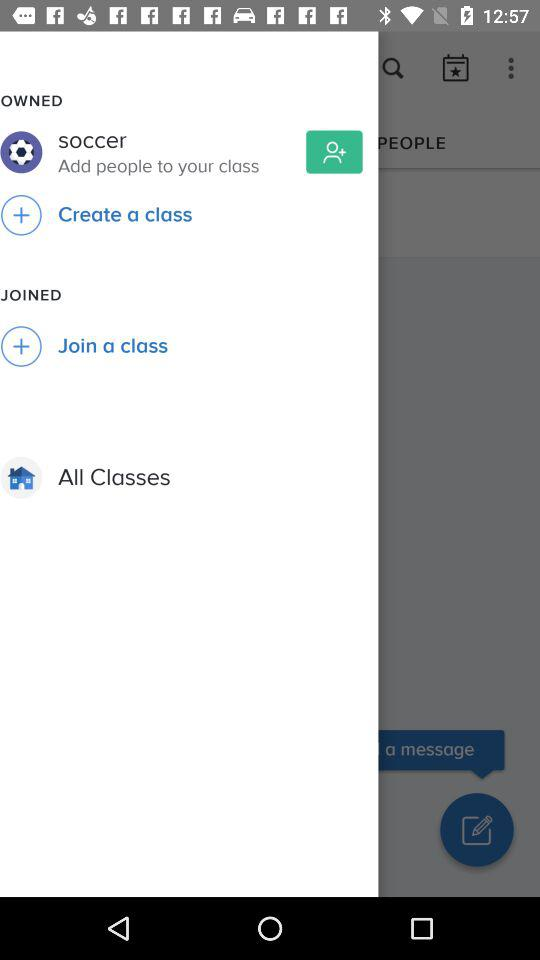What is the name of the created class? The name of the created class is "soccer". 